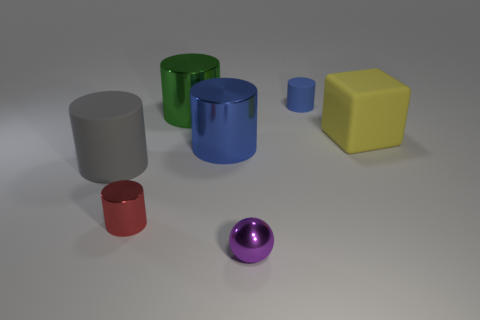Subtract 1 cylinders. How many cylinders are left? 4 Subtract all cyan cylinders. Subtract all green cubes. How many cylinders are left? 5 Add 1 large yellow metal objects. How many objects exist? 8 Subtract all cylinders. How many objects are left? 2 Subtract all large spheres. Subtract all purple things. How many objects are left? 6 Add 1 gray cylinders. How many gray cylinders are left? 2 Add 6 big yellow shiny cubes. How many big yellow shiny cubes exist? 6 Subtract 0 purple cylinders. How many objects are left? 7 